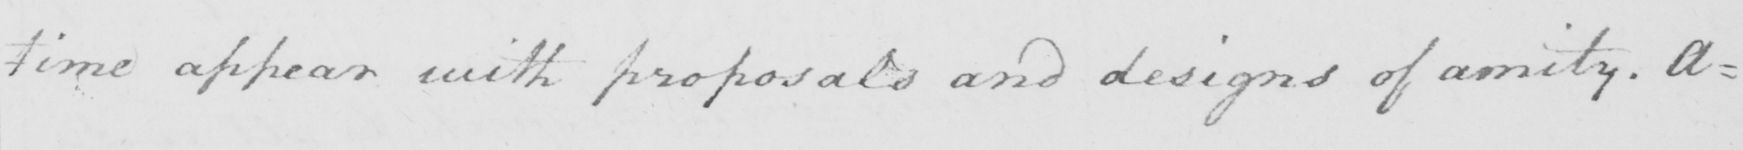What does this handwritten line say? time appear with proposals and designs of amity . A= 